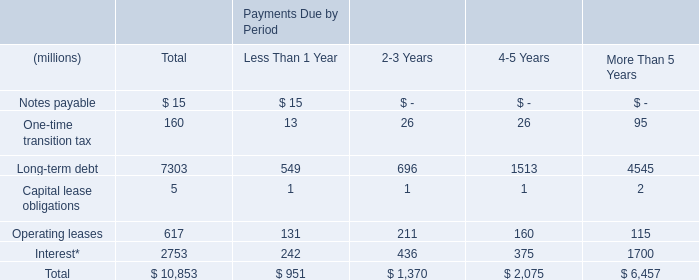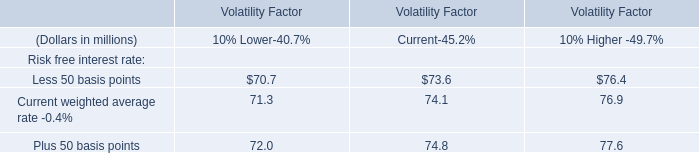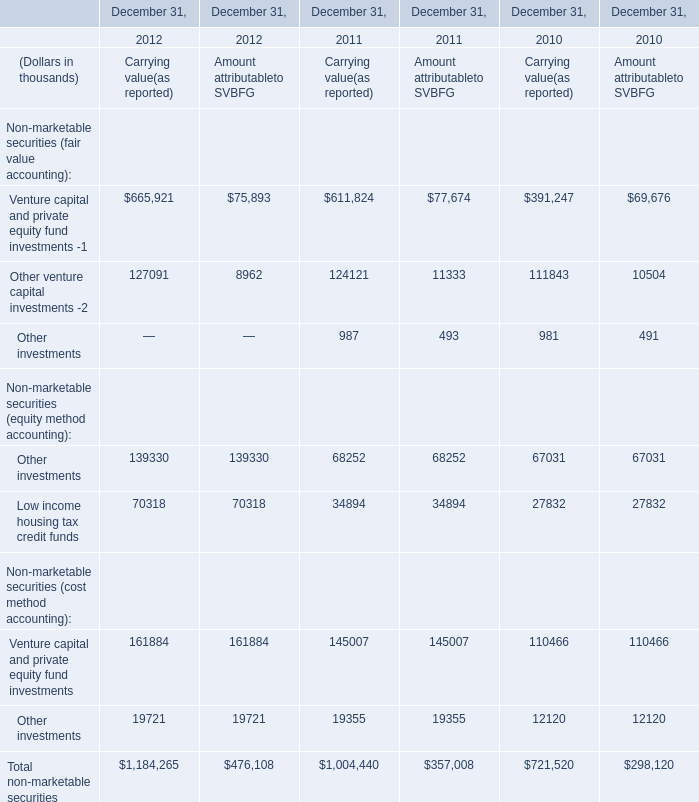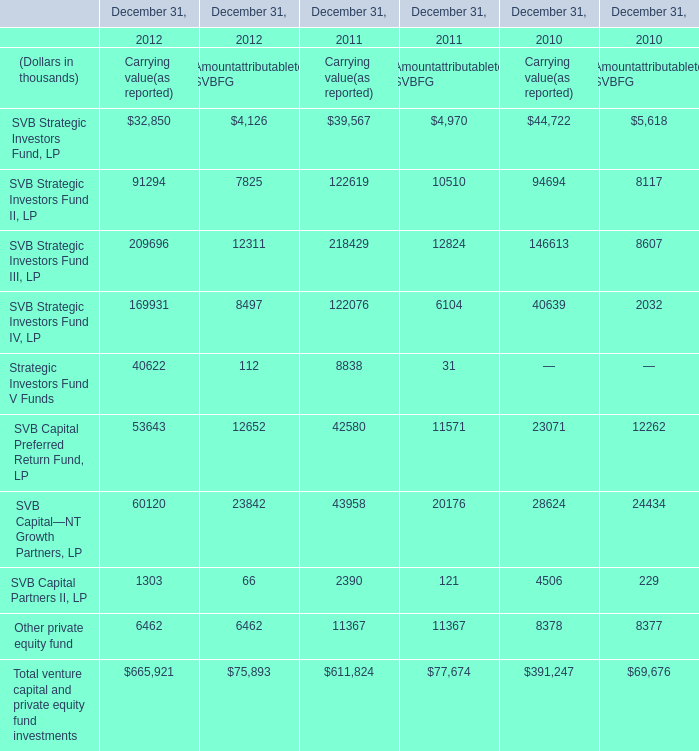what portion of the balance of cash and cash equivalents on hand is held outside u.s . in 2017? 
Computations: (151 / 211)
Answer: 0.71564. 